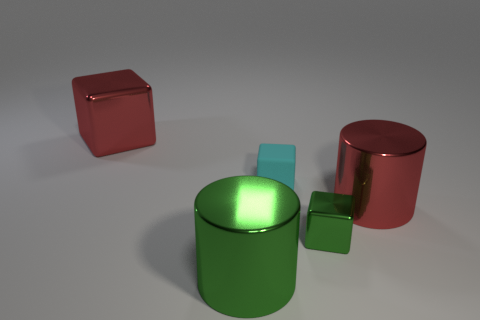Add 4 large green matte cubes. How many objects exist? 9 Subtract all green cubes. How many cubes are left? 2 Subtract 1 blocks. How many blocks are left? 2 Subtract all green shiny cubes. Subtract all tiny yellow metal things. How many objects are left? 4 Add 2 small blocks. How many small blocks are left? 4 Add 4 tiny objects. How many tiny objects exist? 6 Subtract all green cylinders. How many cylinders are left? 1 Subtract 0 yellow cylinders. How many objects are left? 5 Subtract all cylinders. How many objects are left? 3 Subtract all brown cubes. Subtract all blue cylinders. How many cubes are left? 3 